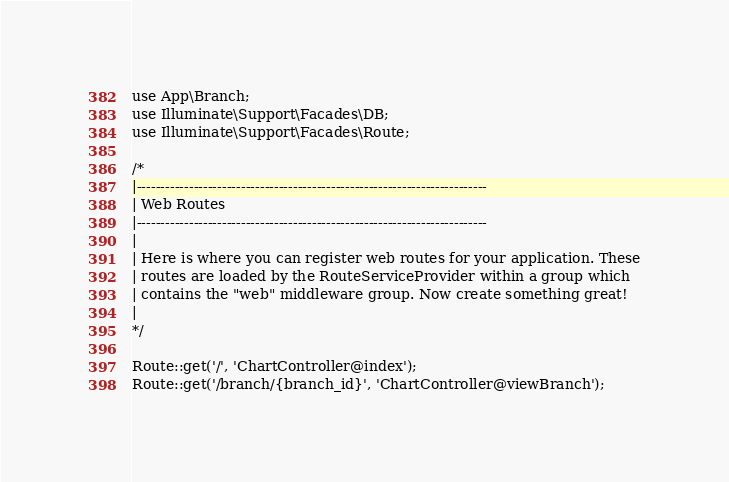Convert code to text. <code><loc_0><loc_0><loc_500><loc_500><_PHP_>
use App\Branch;
use Illuminate\Support\Facades\DB;
use Illuminate\Support\Facades\Route;

/*
|--------------------------------------------------------------------------
| Web Routes
|--------------------------------------------------------------------------
|
| Here is where you can register web routes for your application. These
| routes are loaded by the RouteServiceProvider within a group which
| contains the "web" middleware group. Now create something great!
|
*/

Route::get('/', 'ChartController@index');
Route::get('/branch/{branch_id}', 'ChartController@viewBranch');
</code> 